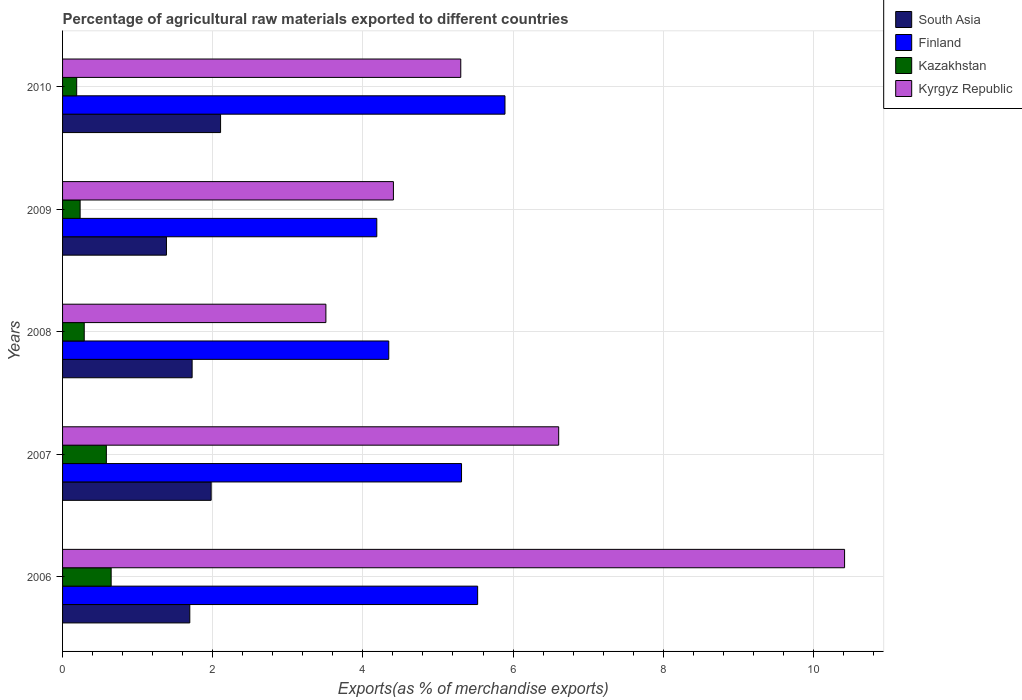How many different coloured bars are there?
Keep it short and to the point. 4. How many bars are there on the 2nd tick from the top?
Your answer should be very brief. 4. How many bars are there on the 5th tick from the bottom?
Provide a succinct answer. 4. What is the label of the 1st group of bars from the top?
Provide a succinct answer. 2010. In how many cases, is the number of bars for a given year not equal to the number of legend labels?
Provide a succinct answer. 0. What is the percentage of exports to different countries in Kyrgyz Republic in 2009?
Give a very brief answer. 4.41. Across all years, what is the maximum percentage of exports to different countries in Kyrgyz Republic?
Your answer should be very brief. 10.42. Across all years, what is the minimum percentage of exports to different countries in Kazakhstan?
Offer a terse response. 0.19. In which year was the percentage of exports to different countries in South Asia minimum?
Offer a terse response. 2009. What is the total percentage of exports to different countries in South Asia in the graph?
Make the answer very short. 8.89. What is the difference between the percentage of exports to different countries in Kazakhstan in 2007 and that in 2008?
Your answer should be compact. 0.29. What is the difference between the percentage of exports to different countries in Kyrgyz Republic in 2009 and the percentage of exports to different countries in Kazakhstan in 2007?
Your response must be concise. 3.82. What is the average percentage of exports to different countries in Finland per year?
Offer a terse response. 5.05. In the year 2006, what is the difference between the percentage of exports to different countries in Kazakhstan and percentage of exports to different countries in South Asia?
Give a very brief answer. -1.05. What is the ratio of the percentage of exports to different countries in Kyrgyz Republic in 2007 to that in 2009?
Make the answer very short. 1.5. Is the percentage of exports to different countries in Kazakhstan in 2007 less than that in 2010?
Provide a succinct answer. No. What is the difference between the highest and the second highest percentage of exports to different countries in Kazakhstan?
Provide a succinct answer. 0.06. What is the difference between the highest and the lowest percentage of exports to different countries in Kazakhstan?
Your response must be concise. 0.46. In how many years, is the percentage of exports to different countries in South Asia greater than the average percentage of exports to different countries in South Asia taken over all years?
Ensure brevity in your answer.  2. Is it the case that in every year, the sum of the percentage of exports to different countries in South Asia and percentage of exports to different countries in Finland is greater than the sum of percentage of exports to different countries in Kazakhstan and percentage of exports to different countries in Kyrgyz Republic?
Your response must be concise. Yes. What does the 3rd bar from the top in 2010 represents?
Provide a succinct answer. Finland. What does the 2nd bar from the bottom in 2006 represents?
Provide a short and direct response. Finland. Is it the case that in every year, the sum of the percentage of exports to different countries in South Asia and percentage of exports to different countries in Kyrgyz Republic is greater than the percentage of exports to different countries in Finland?
Make the answer very short. Yes. How many years are there in the graph?
Your answer should be compact. 5. Does the graph contain any zero values?
Your response must be concise. No. Where does the legend appear in the graph?
Offer a very short reply. Top right. How are the legend labels stacked?
Provide a succinct answer. Vertical. What is the title of the graph?
Your response must be concise. Percentage of agricultural raw materials exported to different countries. What is the label or title of the X-axis?
Offer a very short reply. Exports(as % of merchandise exports). What is the label or title of the Y-axis?
Offer a very short reply. Years. What is the Exports(as % of merchandise exports) of South Asia in 2006?
Offer a terse response. 1.69. What is the Exports(as % of merchandise exports) of Finland in 2006?
Provide a short and direct response. 5.53. What is the Exports(as % of merchandise exports) in Kazakhstan in 2006?
Keep it short and to the point. 0.65. What is the Exports(as % of merchandise exports) of Kyrgyz Republic in 2006?
Give a very brief answer. 10.42. What is the Exports(as % of merchandise exports) of South Asia in 2007?
Your answer should be compact. 1.98. What is the Exports(as % of merchandise exports) of Finland in 2007?
Your response must be concise. 5.31. What is the Exports(as % of merchandise exports) in Kazakhstan in 2007?
Provide a short and direct response. 0.58. What is the Exports(as % of merchandise exports) in Kyrgyz Republic in 2007?
Provide a short and direct response. 6.61. What is the Exports(as % of merchandise exports) of South Asia in 2008?
Make the answer very short. 1.73. What is the Exports(as % of merchandise exports) in Finland in 2008?
Offer a very short reply. 4.34. What is the Exports(as % of merchandise exports) of Kazakhstan in 2008?
Offer a terse response. 0.29. What is the Exports(as % of merchandise exports) of Kyrgyz Republic in 2008?
Your response must be concise. 3.51. What is the Exports(as % of merchandise exports) in South Asia in 2009?
Provide a short and direct response. 1.38. What is the Exports(as % of merchandise exports) in Finland in 2009?
Provide a short and direct response. 4.19. What is the Exports(as % of merchandise exports) of Kazakhstan in 2009?
Offer a terse response. 0.23. What is the Exports(as % of merchandise exports) of Kyrgyz Republic in 2009?
Keep it short and to the point. 4.41. What is the Exports(as % of merchandise exports) of South Asia in 2010?
Your answer should be very brief. 2.1. What is the Exports(as % of merchandise exports) in Finland in 2010?
Make the answer very short. 5.89. What is the Exports(as % of merchandise exports) in Kazakhstan in 2010?
Provide a succinct answer. 0.19. What is the Exports(as % of merchandise exports) in Kyrgyz Republic in 2010?
Your answer should be very brief. 5.3. Across all years, what is the maximum Exports(as % of merchandise exports) of South Asia?
Ensure brevity in your answer.  2.1. Across all years, what is the maximum Exports(as % of merchandise exports) in Finland?
Your answer should be very brief. 5.89. Across all years, what is the maximum Exports(as % of merchandise exports) of Kazakhstan?
Ensure brevity in your answer.  0.65. Across all years, what is the maximum Exports(as % of merchandise exports) in Kyrgyz Republic?
Your answer should be compact. 10.42. Across all years, what is the minimum Exports(as % of merchandise exports) of South Asia?
Keep it short and to the point. 1.38. Across all years, what is the minimum Exports(as % of merchandise exports) in Finland?
Offer a terse response. 4.19. Across all years, what is the minimum Exports(as % of merchandise exports) in Kazakhstan?
Provide a short and direct response. 0.19. Across all years, what is the minimum Exports(as % of merchandise exports) of Kyrgyz Republic?
Your answer should be very brief. 3.51. What is the total Exports(as % of merchandise exports) in South Asia in the graph?
Your answer should be compact. 8.89. What is the total Exports(as % of merchandise exports) of Finland in the graph?
Your response must be concise. 25.27. What is the total Exports(as % of merchandise exports) in Kazakhstan in the graph?
Make the answer very short. 1.94. What is the total Exports(as % of merchandise exports) in Kyrgyz Republic in the graph?
Offer a terse response. 30.24. What is the difference between the Exports(as % of merchandise exports) of South Asia in 2006 and that in 2007?
Give a very brief answer. -0.28. What is the difference between the Exports(as % of merchandise exports) in Finland in 2006 and that in 2007?
Keep it short and to the point. 0.21. What is the difference between the Exports(as % of merchandise exports) in Kazakhstan in 2006 and that in 2007?
Ensure brevity in your answer.  0.06. What is the difference between the Exports(as % of merchandise exports) in Kyrgyz Republic in 2006 and that in 2007?
Your answer should be compact. 3.81. What is the difference between the Exports(as % of merchandise exports) in South Asia in 2006 and that in 2008?
Give a very brief answer. -0.03. What is the difference between the Exports(as % of merchandise exports) in Finland in 2006 and that in 2008?
Offer a terse response. 1.18. What is the difference between the Exports(as % of merchandise exports) of Kazakhstan in 2006 and that in 2008?
Provide a succinct answer. 0.36. What is the difference between the Exports(as % of merchandise exports) of Kyrgyz Republic in 2006 and that in 2008?
Give a very brief answer. 6.91. What is the difference between the Exports(as % of merchandise exports) in South Asia in 2006 and that in 2009?
Provide a short and direct response. 0.31. What is the difference between the Exports(as % of merchandise exports) in Finland in 2006 and that in 2009?
Your answer should be compact. 1.34. What is the difference between the Exports(as % of merchandise exports) in Kazakhstan in 2006 and that in 2009?
Give a very brief answer. 0.41. What is the difference between the Exports(as % of merchandise exports) in Kyrgyz Republic in 2006 and that in 2009?
Provide a succinct answer. 6.01. What is the difference between the Exports(as % of merchandise exports) in South Asia in 2006 and that in 2010?
Your response must be concise. -0.41. What is the difference between the Exports(as % of merchandise exports) of Finland in 2006 and that in 2010?
Make the answer very short. -0.36. What is the difference between the Exports(as % of merchandise exports) in Kazakhstan in 2006 and that in 2010?
Your answer should be compact. 0.46. What is the difference between the Exports(as % of merchandise exports) in Kyrgyz Republic in 2006 and that in 2010?
Offer a terse response. 5.11. What is the difference between the Exports(as % of merchandise exports) in South Asia in 2007 and that in 2008?
Offer a terse response. 0.25. What is the difference between the Exports(as % of merchandise exports) in Finland in 2007 and that in 2008?
Provide a short and direct response. 0.97. What is the difference between the Exports(as % of merchandise exports) in Kazakhstan in 2007 and that in 2008?
Give a very brief answer. 0.29. What is the difference between the Exports(as % of merchandise exports) in Kyrgyz Republic in 2007 and that in 2008?
Your answer should be very brief. 3.1. What is the difference between the Exports(as % of merchandise exports) in South Asia in 2007 and that in 2009?
Offer a terse response. 0.6. What is the difference between the Exports(as % of merchandise exports) in Finland in 2007 and that in 2009?
Give a very brief answer. 1.13. What is the difference between the Exports(as % of merchandise exports) in Kazakhstan in 2007 and that in 2009?
Your answer should be compact. 0.35. What is the difference between the Exports(as % of merchandise exports) in Kyrgyz Republic in 2007 and that in 2009?
Provide a short and direct response. 2.2. What is the difference between the Exports(as % of merchandise exports) in South Asia in 2007 and that in 2010?
Offer a terse response. -0.13. What is the difference between the Exports(as % of merchandise exports) in Finland in 2007 and that in 2010?
Give a very brief answer. -0.58. What is the difference between the Exports(as % of merchandise exports) in Kazakhstan in 2007 and that in 2010?
Offer a very short reply. 0.4. What is the difference between the Exports(as % of merchandise exports) of Kyrgyz Republic in 2007 and that in 2010?
Ensure brevity in your answer.  1.3. What is the difference between the Exports(as % of merchandise exports) in South Asia in 2008 and that in 2009?
Your answer should be very brief. 0.34. What is the difference between the Exports(as % of merchandise exports) of Finland in 2008 and that in 2009?
Ensure brevity in your answer.  0.16. What is the difference between the Exports(as % of merchandise exports) in Kazakhstan in 2008 and that in 2009?
Provide a short and direct response. 0.05. What is the difference between the Exports(as % of merchandise exports) in Kyrgyz Republic in 2008 and that in 2009?
Ensure brevity in your answer.  -0.9. What is the difference between the Exports(as % of merchandise exports) of South Asia in 2008 and that in 2010?
Make the answer very short. -0.38. What is the difference between the Exports(as % of merchandise exports) of Finland in 2008 and that in 2010?
Your answer should be very brief. -1.55. What is the difference between the Exports(as % of merchandise exports) in Kazakhstan in 2008 and that in 2010?
Offer a terse response. 0.1. What is the difference between the Exports(as % of merchandise exports) in Kyrgyz Republic in 2008 and that in 2010?
Your answer should be compact. -1.8. What is the difference between the Exports(as % of merchandise exports) in South Asia in 2009 and that in 2010?
Keep it short and to the point. -0.72. What is the difference between the Exports(as % of merchandise exports) of Finland in 2009 and that in 2010?
Make the answer very short. -1.71. What is the difference between the Exports(as % of merchandise exports) of Kazakhstan in 2009 and that in 2010?
Your response must be concise. 0.05. What is the difference between the Exports(as % of merchandise exports) in Kyrgyz Republic in 2009 and that in 2010?
Keep it short and to the point. -0.9. What is the difference between the Exports(as % of merchandise exports) in South Asia in 2006 and the Exports(as % of merchandise exports) in Finland in 2007?
Your answer should be compact. -3.62. What is the difference between the Exports(as % of merchandise exports) of South Asia in 2006 and the Exports(as % of merchandise exports) of Kazakhstan in 2007?
Your response must be concise. 1.11. What is the difference between the Exports(as % of merchandise exports) in South Asia in 2006 and the Exports(as % of merchandise exports) in Kyrgyz Republic in 2007?
Your answer should be compact. -4.91. What is the difference between the Exports(as % of merchandise exports) in Finland in 2006 and the Exports(as % of merchandise exports) in Kazakhstan in 2007?
Your answer should be compact. 4.95. What is the difference between the Exports(as % of merchandise exports) in Finland in 2006 and the Exports(as % of merchandise exports) in Kyrgyz Republic in 2007?
Offer a terse response. -1.08. What is the difference between the Exports(as % of merchandise exports) in Kazakhstan in 2006 and the Exports(as % of merchandise exports) in Kyrgyz Republic in 2007?
Provide a succinct answer. -5.96. What is the difference between the Exports(as % of merchandise exports) of South Asia in 2006 and the Exports(as % of merchandise exports) of Finland in 2008?
Keep it short and to the point. -2.65. What is the difference between the Exports(as % of merchandise exports) of South Asia in 2006 and the Exports(as % of merchandise exports) of Kazakhstan in 2008?
Make the answer very short. 1.41. What is the difference between the Exports(as % of merchandise exports) of South Asia in 2006 and the Exports(as % of merchandise exports) of Kyrgyz Republic in 2008?
Keep it short and to the point. -1.81. What is the difference between the Exports(as % of merchandise exports) in Finland in 2006 and the Exports(as % of merchandise exports) in Kazakhstan in 2008?
Provide a succinct answer. 5.24. What is the difference between the Exports(as % of merchandise exports) in Finland in 2006 and the Exports(as % of merchandise exports) in Kyrgyz Republic in 2008?
Offer a terse response. 2.02. What is the difference between the Exports(as % of merchandise exports) of Kazakhstan in 2006 and the Exports(as % of merchandise exports) of Kyrgyz Republic in 2008?
Your answer should be compact. -2.86. What is the difference between the Exports(as % of merchandise exports) of South Asia in 2006 and the Exports(as % of merchandise exports) of Finland in 2009?
Your answer should be compact. -2.49. What is the difference between the Exports(as % of merchandise exports) of South Asia in 2006 and the Exports(as % of merchandise exports) of Kazakhstan in 2009?
Make the answer very short. 1.46. What is the difference between the Exports(as % of merchandise exports) of South Asia in 2006 and the Exports(as % of merchandise exports) of Kyrgyz Republic in 2009?
Give a very brief answer. -2.71. What is the difference between the Exports(as % of merchandise exports) of Finland in 2006 and the Exports(as % of merchandise exports) of Kazakhstan in 2009?
Keep it short and to the point. 5.29. What is the difference between the Exports(as % of merchandise exports) in Finland in 2006 and the Exports(as % of merchandise exports) in Kyrgyz Republic in 2009?
Keep it short and to the point. 1.12. What is the difference between the Exports(as % of merchandise exports) of Kazakhstan in 2006 and the Exports(as % of merchandise exports) of Kyrgyz Republic in 2009?
Give a very brief answer. -3.76. What is the difference between the Exports(as % of merchandise exports) in South Asia in 2006 and the Exports(as % of merchandise exports) in Finland in 2010?
Your answer should be very brief. -4.2. What is the difference between the Exports(as % of merchandise exports) of South Asia in 2006 and the Exports(as % of merchandise exports) of Kazakhstan in 2010?
Offer a very short reply. 1.51. What is the difference between the Exports(as % of merchandise exports) of South Asia in 2006 and the Exports(as % of merchandise exports) of Kyrgyz Republic in 2010?
Provide a succinct answer. -3.61. What is the difference between the Exports(as % of merchandise exports) in Finland in 2006 and the Exports(as % of merchandise exports) in Kazakhstan in 2010?
Keep it short and to the point. 5.34. What is the difference between the Exports(as % of merchandise exports) in Finland in 2006 and the Exports(as % of merchandise exports) in Kyrgyz Republic in 2010?
Your answer should be compact. 0.23. What is the difference between the Exports(as % of merchandise exports) of Kazakhstan in 2006 and the Exports(as % of merchandise exports) of Kyrgyz Republic in 2010?
Your response must be concise. -4.66. What is the difference between the Exports(as % of merchandise exports) in South Asia in 2007 and the Exports(as % of merchandise exports) in Finland in 2008?
Keep it short and to the point. -2.37. What is the difference between the Exports(as % of merchandise exports) in South Asia in 2007 and the Exports(as % of merchandise exports) in Kazakhstan in 2008?
Your response must be concise. 1.69. What is the difference between the Exports(as % of merchandise exports) in South Asia in 2007 and the Exports(as % of merchandise exports) in Kyrgyz Republic in 2008?
Provide a succinct answer. -1.53. What is the difference between the Exports(as % of merchandise exports) in Finland in 2007 and the Exports(as % of merchandise exports) in Kazakhstan in 2008?
Your answer should be very brief. 5.03. What is the difference between the Exports(as % of merchandise exports) in Finland in 2007 and the Exports(as % of merchandise exports) in Kyrgyz Republic in 2008?
Give a very brief answer. 1.81. What is the difference between the Exports(as % of merchandise exports) in Kazakhstan in 2007 and the Exports(as % of merchandise exports) in Kyrgyz Republic in 2008?
Your response must be concise. -2.92. What is the difference between the Exports(as % of merchandise exports) of South Asia in 2007 and the Exports(as % of merchandise exports) of Finland in 2009?
Offer a terse response. -2.21. What is the difference between the Exports(as % of merchandise exports) of South Asia in 2007 and the Exports(as % of merchandise exports) of Kazakhstan in 2009?
Make the answer very short. 1.75. What is the difference between the Exports(as % of merchandise exports) of South Asia in 2007 and the Exports(as % of merchandise exports) of Kyrgyz Republic in 2009?
Ensure brevity in your answer.  -2.43. What is the difference between the Exports(as % of merchandise exports) in Finland in 2007 and the Exports(as % of merchandise exports) in Kazakhstan in 2009?
Offer a terse response. 5.08. What is the difference between the Exports(as % of merchandise exports) in Finland in 2007 and the Exports(as % of merchandise exports) in Kyrgyz Republic in 2009?
Your response must be concise. 0.91. What is the difference between the Exports(as % of merchandise exports) in Kazakhstan in 2007 and the Exports(as % of merchandise exports) in Kyrgyz Republic in 2009?
Ensure brevity in your answer.  -3.82. What is the difference between the Exports(as % of merchandise exports) of South Asia in 2007 and the Exports(as % of merchandise exports) of Finland in 2010?
Provide a short and direct response. -3.91. What is the difference between the Exports(as % of merchandise exports) of South Asia in 2007 and the Exports(as % of merchandise exports) of Kazakhstan in 2010?
Offer a very short reply. 1.79. What is the difference between the Exports(as % of merchandise exports) of South Asia in 2007 and the Exports(as % of merchandise exports) of Kyrgyz Republic in 2010?
Provide a succinct answer. -3.32. What is the difference between the Exports(as % of merchandise exports) in Finland in 2007 and the Exports(as % of merchandise exports) in Kazakhstan in 2010?
Your answer should be compact. 5.13. What is the difference between the Exports(as % of merchandise exports) in Finland in 2007 and the Exports(as % of merchandise exports) in Kyrgyz Republic in 2010?
Provide a short and direct response. 0.01. What is the difference between the Exports(as % of merchandise exports) in Kazakhstan in 2007 and the Exports(as % of merchandise exports) in Kyrgyz Republic in 2010?
Offer a very short reply. -4.72. What is the difference between the Exports(as % of merchandise exports) in South Asia in 2008 and the Exports(as % of merchandise exports) in Finland in 2009?
Provide a short and direct response. -2.46. What is the difference between the Exports(as % of merchandise exports) of South Asia in 2008 and the Exports(as % of merchandise exports) of Kazakhstan in 2009?
Your answer should be very brief. 1.49. What is the difference between the Exports(as % of merchandise exports) of South Asia in 2008 and the Exports(as % of merchandise exports) of Kyrgyz Republic in 2009?
Your response must be concise. -2.68. What is the difference between the Exports(as % of merchandise exports) of Finland in 2008 and the Exports(as % of merchandise exports) of Kazakhstan in 2009?
Provide a succinct answer. 4.11. What is the difference between the Exports(as % of merchandise exports) of Finland in 2008 and the Exports(as % of merchandise exports) of Kyrgyz Republic in 2009?
Make the answer very short. -0.06. What is the difference between the Exports(as % of merchandise exports) in Kazakhstan in 2008 and the Exports(as % of merchandise exports) in Kyrgyz Republic in 2009?
Your answer should be very brief. -4.12. What is the difference between the Exports(as % of merchandise exports) in South Asia in 2008 and the Exports(as % of merchandise exports) in Finland in 2010?
Your answer should be compact. -4.17. What is the difference between the Exports(as % of merchandise exports) in South Asia in 2008 and the Exports(as % of merchandise exports) in Kazakhstan in 2010?
Your answer should be very brief. 1.54. What is the difference between the Exports(as % of merchandise exports) in South Asia in 2008 and the Exports(as % of merchandise exports) in Kyrgyz Republic in 2010?
Your response must be concise. -3.58. What is the difference between the Exports(as % of merchandise exports) of Finland in 2008 and the Exports(as % of merchandise exports) of Kazakhstan in 2010?
Keep it short and to the point. 4.16. What is the difference between the Exports(as % of merchandise exports) in Finland in 2008 and the Exports(as % of merchandise exports) in Kyrgyz Republic in 2010?
Offer a terse response. -0.96. What is the difference between the Exports(as % of merchandise exports) of Kazakhstan in 2008 and the Exports(as % of merchandise exports) of Kyrgyz Republic in 2010?
Your answer should be compact. -5.01. What is the difference between the Exports(as % of merchandise exports) of South Asia in 2009 and the Exports(as % of merchandise exports) of Finland in 2010?
Offer a terse response. -4.51. What is the difference between the Exports(as % of merchandise exports) of South Asia in 2009 and the Exports(as % of merchandise exports) of Kazakhstan in 2010?
Your answer should be compact. 1.2. What is the difference between the Exports(as % of merchandise exports) of South Asia in 2009 and the Exports(as % of merchandise exports) of Kyrgyz Republic in 2010?
Your response must be concise. -3.92. What is the difference between the Exports(as % of merchandise exports) of Finland in 2009 and the Exports(as % of merchandise exports) of Kazakhstan in 2010?
Give a very brief answer. 4. What is the difference between the Exports(as % of merchandise exports) of Finland in 2009 and the Exports(as % of merchandise exports) of Kyrgyz Republic in 2010?
Provide a succinct answer. -1.12. What is the difference between the Exports(as % of merchandise exports) in Kazakhstan in 2009 and the Exports(as % of merchandise exports) in Kyrgyz Republic in 2010?
Offer a terse response. -5.07. What is the average Exports(as % of merchandise exports) in South Asia per year?
Provide a succinct answer. 1.78. What is the average Exports(as % of merchandise exports) of Finland per year?
Your response must be concise. 5.05. What is the average Exports(as % of merchandise exports) in Kazakhstan per year?
Give a very brief answer. 0.39. What is the average Exports(as % of merchandise exports) in Kyrgyz Republic per year?
Give a very brief answer. 6.05. In the year 2006, what is the difference between the Exports(as % of merchandise exports) of South Asia and Exports(as % of merchandise exports) of Finland?
Give a very brief answer. -3.83. In the year 2006, what is the difference between the Exports(as % of merchandise exports) in South Asia and Exports(as % of merchandise exports) in Kazakhstan?
Provide a short and direct response. 1.05. In the year 2006, what is the difference between the Exports(as % of merchandise exports) in South Asia and Exports(as % of merchandise exports) in Kyrgyz Republic?
Ensure brevity in your answer.  -8.72. In the year 2006, what is the difference between the Exports(as % of merchandise exports) in Finland and Exports(as % of merchandise exports) in Kazakhstan?
Your answer should be compact. 4.88. In the year 2006, what is the difference between the Exports(as % of merchandise exports) in Finland and Exports(as % of merchandise exports) in Kyrgyz Republic?
Your answer should be very brief. -4.89. In the year 2006, what is the difference between the Exports(as % of merchandise exports) of Kazakhstan and Exports(as % of merchandise exports) of Kyrgyz Republic?
Offer a very short reply. -9.77. In the year 2007, what is the difference between the Exports(as % of merchandise exports) of South Asia and Exports(as % of merchandise exports) of Finland?
Offer a terse response. -3.33. In the year 2007, what is the difference between the Exports(as % of merchandise exports) of South Asia and Exports(as % of merchandise exports) of Kazakhstan?
Offer a very short reply. 1.4. In the year 2007, what is the difference between the Exports(as % of merchandise exports) in South Asia and Exports(as % of merchandise exports) in Kyrgyz Republic?
Your response must be concise. -4.63. In the year 2007, what is the difference between the Exports(as % of merchandise exports) in Finland and Exports(as % of merchandise exports) in Kazakhstan?
Provide a succinct answer. 4.73. In the year 2007, what is the difference between the Exports(as % of merchandise exports) in Finland and Exports(as % of merchandise exports) in Kyrgyz Republic?
Ensure brevity in your answer.  -1.29. In the year 2007, what is the difference between the Exports(as % of merchandise exports) in Kazakhstan and Exports(as % of merchandise exports) in Kyrgyz Republic?
Your answer should be compact. -6.02. In the year 2008, what is the difference between the Exports(as % of merchandise exports) of South Asia and Exports(as % of merchandise exports) of Finland?
Make the answer very short. -2.62. In the year 2008, what is the difference between the Exports(as % of merchandise exports) in South Asia and Exports(as % of merchandise exports) in Kazakhstan?
Make the answer very short. 1.44. In the year 2008, what is the difference between the Exports(as % of merchandise exports) in South Asia and Exports(as % of merchandise exports) in Kyrgyz Republic?
Give a very brief answer. -1.78. In the year 2008, what is the difference between the Exports(as % of merchandise exports) of Finland and Exports(as % of merchandise exports) of Kazakhstan?
Your response must be concise. 4.06. In the year 2008, what is the difference between the Exports(as % of merchandise exports) in Finland and Exports(as % of merchandise exports) in Kyrgyz Republic?
Make the answer very short. 0.84. In the year 2008, what is the difference between the Exports(as % of merchandise exports) in Kazakhstan and Exports(as % of merchandise exports) in Kyrgyz Republic?
Your answer should be compact. -3.22. In the year 2009, what is the difference between the Exports(as % of merchandise exports) of South Asia and Exports(as % of merchandise exports) of Finland?
Provide a short and direct response. -2.8. In the year 2009, what is the difference between the Exports(as % of merchandise exports) of South Asia and Exports(as % of merchandise exports) of Kazakhstan?
Keep it short and to the point. 1.15. In the year 2009, what is the difference between the Exports(as % of merchandise exports) in South Asia and Exports(as % of merchandise exports) in Kyrgyz Republic?
Offer a very short reply. -3.02. In the year 2009, what is the difference between the Exports(as % of merchandise exports) of Finland and Exports(as % of merchandise exports) of Kazakhstan?
Provide a short and direct response. 3.95. In the year 2009, what is the difference between the Exports(as % of merchandise exports) of Finland and Exports(as % of merchandise exports) of Kyrgyz Republic?
Give a very brief answer. -0.22. In the year 2009, what is the difference between the Exports(as % of merchandise exports) in Kazakhstan and Exports(as % of merchandise exports) in Kyrgyz Republic?
Ensure brevity in your answer.  -4.17. In the year 2010, what is the difference between the Exports(as % of merchandise exports) of South Asia and Exports(as % of merchandise exports) of Finland?
Your answer should be very brief. -3.79. In the year 2010, what is the difference between the Exports(as % of merchandise exports) in South Asia and Exports(as % of merchandise exports) in Kazakhstan?
Offer a very short reply. 1.92. In the year 2010, what is the difference between the Exports(as % of merchandise exports) of South Asia and Exports(as % of merchandise exports) of Kyrgyz Republic?
Your answer should be very brief. -3.2. In the year 2010, what is the difference between the Exports(as % of merchandise exports) in Finland and Exports(as % of merchandise exports) in Kazakhstan?
Provide a short and direct response. 5.7. In the year 2010, what is the difference between the Exports(as % of merchandise exports) of Finland and Exports(as % of merchandise exports) of Kyrgyz Republic?
Make the answer very short. 0.59. In the year 2010, what is the difference between the Exports(as % of merchandise exports) in Kazakhstan and Exports(as % of merchandise exports) in Kyrgyz Republic?
Your response must be concise. -5.12. What is the ratio of the Exports(as % of merchandise exports) of South Asia in 2006 to that in 2007?
Offer a terse response. 0.86. What is the ratio of the Exports(as % of merchandise exports) of Finland in 2006 to that in 2007?
Provide a short and direct response. 1.04. What is the ratio of the Exports(as % of merchandise exports) of Kazakhstan in 2006 to that in 2007?
Your answer should be very brief. 1.11. What is the ratio of the Exports(as % of merchandise exports) of Kyrgyz Republic in 2006 to that in 2007?
Offer a terse response. 1.58. What is the ratio of the Exports(as % of merchandise exports) in South Asia in 2006 to that in 2008?
Keep it short and to the point. 0.98. What is the ratio of the Exports(as % of merchandise exports) in Finland in 2006 to that in 2008?
Offer a terse response. 1.27. What is the ratio of the Exports(as % of merchandise exports) in Kazakhstan in 2006 to that in 2008?
Offer a terse response. 2.24. What is the ratio of the Exports(as % of merchandise exports) in Kyrgyz Republic in 2006 to that in 2008?
Ensure brevity in your answer.  2.97. What is the ratio of the Exports(as % of merchandise exports) of South Asia in 2006 to that in 2009?
Offer a very short reply. 1.22. What is the ratio of the Exports(as % of merchandise exports) in Finland in 2006 to that in 2009?
Provide a short and direct response. 1.32. What is the ratio of the Exports(as % of merchandise exports) in Kazakhstan in 2006 to that in 2009?
Offer a terse response. 2.77. What is the ratio of the Exports(as % of merchandise exports) in Kyrgyz Republic in 2006 to that in 2009?
Make the answer very short. 2.36. What is the ratio of the Exports(as % of merchandise exports) of South Asia in 2006 to that in 2010?
Ensure brevity in your answer.  0.81. What is the ratio of the Exports(as % of merchandise exports) of Finland in 2006 to that in 2010?
Your response must be concise. 0.94. What is the ratio of the Exports(as % of merchandise exports) in Kazakhstan in 2006 to that in 2010?
Your answer should be compact. 3.44. What is the ratio of the Exports(as % of merchandise exports) in Kyrgyz Republic in 2006 to that in 2010?
Make the answer very short. 1.96. What is the ratio of the Exports(as % of merchandise exports) in South Asia in 2007 to that in 2008?
Provide a succinct answer. 1.15. What is the ratio of the Exports(as % of merchandise exports) in Finland in 2007 to that in 2008?
Offer a very short reply. 1.22. What is the ratio of the Exports(as % of merchandise exports) of Kazakhstan in 2007 to that in 2008?
Your answer should be compact. 2.02. What is the ratio of the Exports(as % of merchandise exports) in Kyrgyz Republic in 2007 to that in 2008?
Provide a succinct answer. 1.88. What is the ratio of the Exports(as % of merchandise exports) in South Asia in 2007 to that in 2009?
Your answer should be compact. 1.43. What is the ratio of the Exports(as % of merchandise exports) in Finland in 2007 to that in 2009?
Your answer should be very brief. 1.27. What is the ratio of the Exports(as % of merchandise exports) of Kazakhstan in 2007 to that in 2009?
Your answer should be compact. 2.49. What is the ratio of the Exports(as % of merchandise exports) in Kyrgyz Republic in 2007 to that in 2009?
Give a very brief answer. 1.5. What is the ratio of the Exports(as % of merchandise exports) of South Asia in 2007 to that in 2010?
Give a very brief answer. 0.94. What is the ratio of the Exports(as % of merchandise exports) in Finland in 2007 to that in 2010?
Your answer should be compact. 0.9. What is the ratio of the Exports(as % of merchandise exports) in Kazakhstan in 2007 to that in 2010?
Offer a very short reply. 3.1. What is the ratio of the Exports(as % of merchandise exports) in Kyrgyz Republic in 2007 to that in 2010?
Offer a terse response. 1.25. What is the ratio of the Exports(as % of merchandise exports) in South Asia in 2008 to that in 2009?
Provide a succinct answer. 1.25. What is the ratio of the Exports(as % of merchandise exports) in Finland in 2008 to that in 2009?
Provide a short and direct response. 1.04. What is the ratio of the Exports(as % of merchandise exports) in Kazakhstan in 2008 to that in 2009?
Your answer should be compact. 1.23. What is the ratio of the Exports(as % of merchandise exports) of Kyrgyz Republic in 2008 to that in 2009?
Keep it short and to the point. 0.8. What is the ratio of the Exports(as % of merchandise exports) in South Asia in 2008 to that in 2010?
Your response must be concise. 0.82. What is the ratio of the Exports(as % of merchandise exports) in Finland in 2008 to that in 2010?
Give a very brief answer. 0.74. What is the ratio of the Exports(as % of merchandise exports) of Kazakhstan in 2008 to that in 2010?
Give a very brief answer. 1.54. What is the ratio of the Exports(as % of merchandise exports) in Kyrgyz Republic in 2008 to that in 2010?
Make the answer very short. 0.66. What is the ratio of the Exports(as % of merchandise exports) in South Asia in 2009 to that in 2010?
Your answer should be compact. 0.66. What is the ratio of the Exports(as % of merchandise exports) of Finland in 2009 to that in 2010?
Your response must be concise. 0.71. What is the ratio of the Exports(as % of merchandise exports) of Kazakhstan in 2009 to that in 2010?
Your response must be concise. 1.24. What is the ratio of the Exports(as % of merchandise exports) of Kyrgyz Republic in 2009 to that in 2010?
Keep it short and to the point. 0.83. What is the difference between the highest and the second highest Exports(as % of merchandise exports) in South Asia?
Your answer should be compact. 0.13. What is the difference between the highest and the second highest Exports(as % of merchandise exports) of Finland?
Give a very brief answer. 0.36. What is the difference between the highest and the second highest Exports(as % of merchandise exports) of Kazakhstan?
Offer a very short reply. 0.06. What is the difference between the highest and the second highest Exports(as % of merchandise exports) in Kyrgyz Republic?
Offer a terse response. 3.81. What is the difference between the highest and the lowest Exports(as % of merchandise exports) of South Asia?
Provide a short and direct response. 0.72. What is the difference between the highest and the lowest Exports(as % of merchandise exports) of Finland?
Your answer should be very brief. 1.71. What is the difference between the highest and the lowest Exports(as % of merchandise exports) in Kazakhstan?
Offer a very short reply. 0.46. What is the difference between the highest and the lowest Exports(as % of merchandise exports) of Kyrgyz Republic?
Provide a short and direct response. 6.91. 